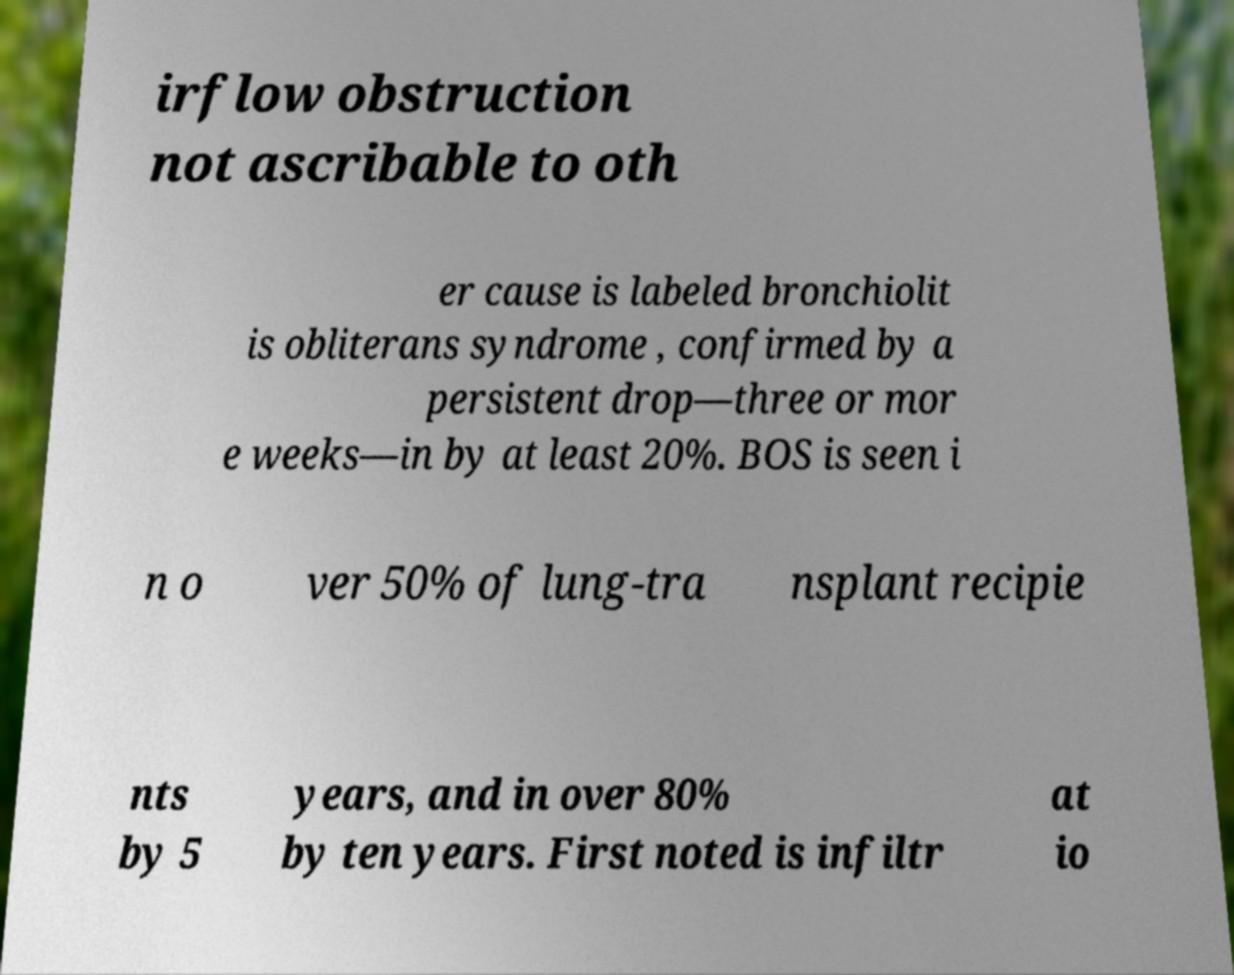Please identify and transcribe the text found in this image. irflow obstruction not ascribable to oth er cause is labeled bronchiolit is obliterans syndrome , confirmed by a persistent drop—three or mor e weeks—in by at least 20%. BOS is seen i n o ver 50% of lung-tra nsplant recipie nts by 5 years, and in over 80% by ten years. First noted is infiltr at io 